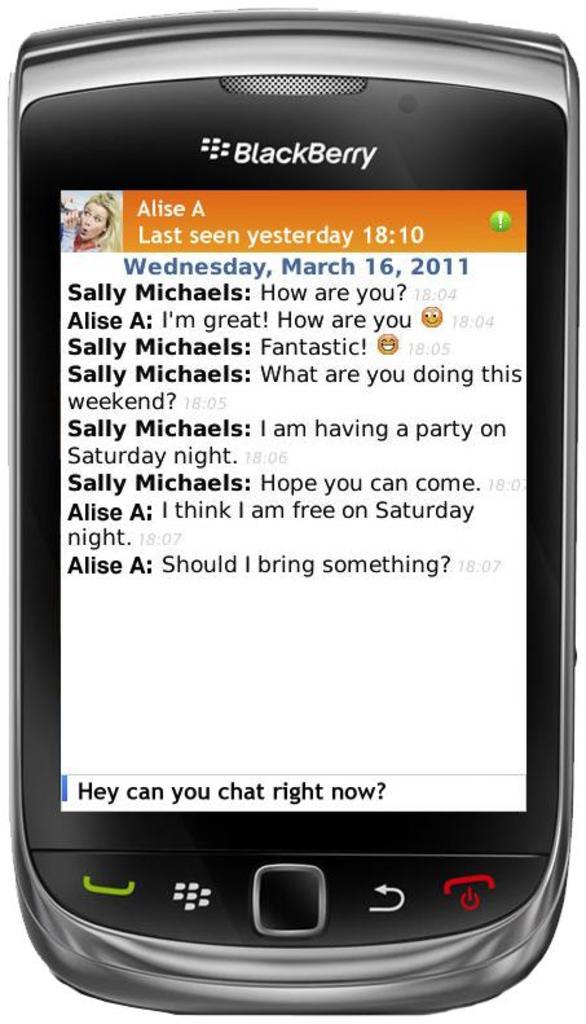What is the name of the person being messaged?
Provide a succinct answer. Alise a. What is the brand of this phone?
Offer a terse response. Blackberry. 